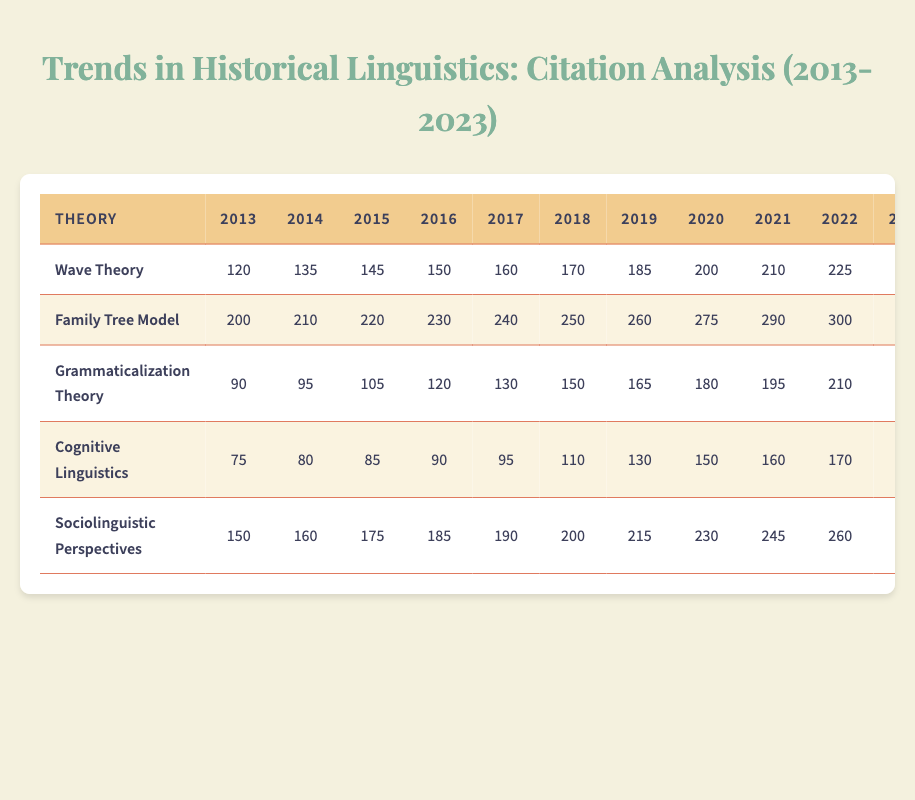What was the highest number of citations for Wave Theory in 2023? The table shows that Wave Theory had 240 citations in 2023, as indicated in the row corresponding to the year 2023 and the column for Wave Theory.
Answer: 240 In which year did the Family Tree Model record its first citation of 200? The Family Tree Model first achieved 200 citations in 2013, the first year listed in the table, as found in the respective row.
Answer: 2013 What was the total number of citations for Grammaticalization Theory from 2013 to 2023? To find the total, sum the citations: 90 + 95 + 105 + 120 + 130 + 150 + 165 + 180 + 195 + 210 + 220 = 1,765. Therefore, the total for Grammaticalization Theory is 1,765.
Answer: 1765 Did Sociolinguistic Perspectives have more citations than Cognitive Linguistics in every year from 2013 to 2023? By comparing the citations year by year, I see that Sociolinguistic Perspectives consistently exceeds Cognitive Linguistics each year from 2013 to 2023, confirming that it did indeed have more citations every year.
Answer: Yes What was the trend in citations for Cognitive Linguistics from 2013 to 2023? Analyzing the citations, we see that they increased from 75 in 2013 to 180 in 2023. This indicates a growing trend over the decade, where the values appear in ascending order year by year, reflecting a consistent increase.
Answer: Increasing 